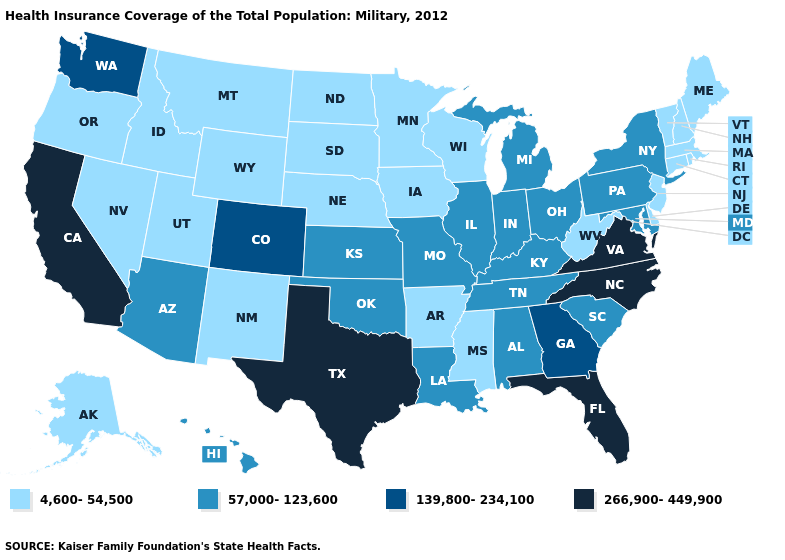What is the lowest value in the South?
Short answer required. 4,600-54,500. Name the states that have a value in the range 266,900-449,900?
Be succinct. California, Florida, North Carolina, Texas, Virginia. Does Nebraska have the highest value in the MidWest?
Give a very brief answer. No. What is the value of Hawaii?
Concise answer only. 57,000-123,600. Does North Carolina have the highest value in the USA?
Give a very brief answer. Yes. What is the value of Alaska?
Short answer required. 4,600-54,500. What is the value of Maryland?
Be succinct. 57,000-123,600. Name the states that have a value in the range 266,900-449,900?
Short answer required. California, Florida, North Carolina, Texas, Virginia. Does Virginia have the highest value in the South?
Quick response, please. Yes. Does Pennsylvania have a higher value than Alaska?
Quick response, please. Yes. Which states have the highest value in the USA?
Give a very brief answer. California, Florida, North Carolina, Texas, Virginia. Name the states that have a value in the range 266,900-449,900?
Keep it brief. California, Florida, North Carolina, Texas, Virginia. Does Tennessee have the same value as California?
Short answer required. No. 